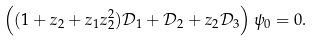Convert formula to latex. <formula><loc_0><loc_0><loc_500><loc_500>\left ( ( 1 + z _ { 2 } + z _ { 1 } z _ { 2 } ^ { 2 } ) \mathcal { D } _ { 1 } + \mathcal { D } _ { 2 } + z _ { 2 } \mathcal { D } _ { 3 } \right ) \psi _ { 0 } = 0 .</formula> 